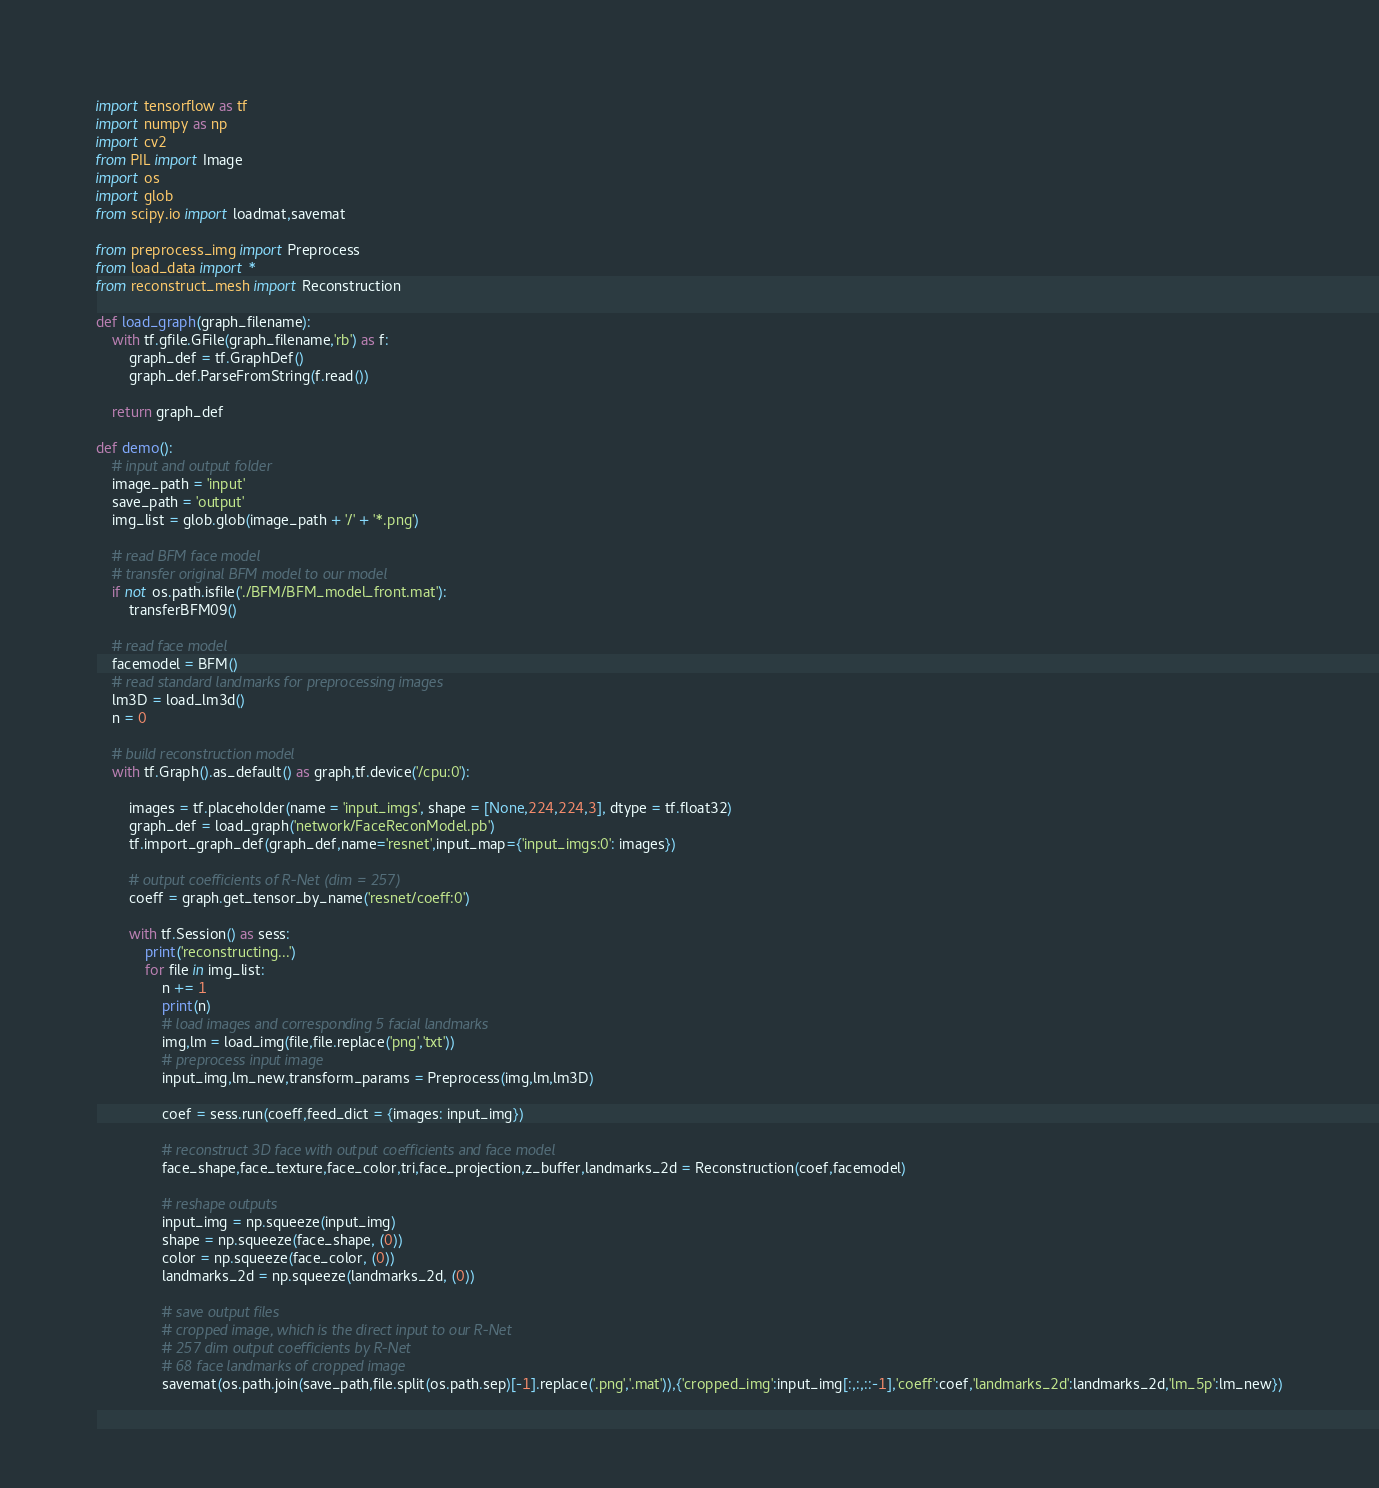Convert code to text. <code><loc_0><loc_0><loc_500><loc_500><_Python_>import tensorflow as tf 
import numpy as np
import cv2
from PIL import Image
import os
import glob
from scipy.io import loadmat,savemat

from preprocess_img import Preprocess
from load_data import *
from reconstruct_mesh import Reconstruction

def load_graph(graph_filename):
	with tf.gfile.GFile(graph_filename,'rb') as f:
		graph_def = tf.GraphDef()
		graph_def.ParseFromString(f.read())

	return graph_def

def demo():
	# input and output folder
	image_path = 'input'
	save_path = 'output'	
	img_list = glob.glob(image_path + '/' + '*.png')

	# read BFM face model
	# transfer original BFM model to our model
	if not os.path.isfile('./BFM/BFM_model_front.mat'):
		transferBFM09()

	# read face model
	facemodel = BFM()
	# read standard landmarks for preprocessing images
	lm3D = load_lm3d()
	n = 0

	# build reconstruction model
	with tf.Graph().as_default() as graph,tf.device('/cpu:0'):

		images = tf.placeholder(name = 'input_imgs', shape = [None,224,224,3], dtype = tf.float32)
		graph_def = load_graph('network/FaceReconModel.pb')
		tf.import_graph_def(graph_def,name='resnet',input_map={'input_imgs:0': images})

		# output coefficients of R-Net (dim = 257) 
		coeff = graph.get_tensor_by_name('resnet/coeff:0')

		with tf.Session() as sess:
			print('reconstructing...')
			for file in img_list:
				n += 1
				print(n)
				# load images and corresponding 5 facial landmarks
				img,lm = load_img(file,file.replace('png','txt'))
				# preprocess input image
				input_img,lm_new,transform_params = Preprocess(img,lm,lm3D)

				coef = sess.run(coeff,feed_dict = {images: input_img})

				# reconstruct 3D face with output coefficients and face model
				face_shape,face_texture,face_color,tri,face_projection,z_buffer,landmarks_2d = Reconstruction(coef,facemodel)

				# reshape outputs
				input_img = np.squeeze(input_img)
				shape = np.squeeze(face_shape, (0))
				color = np.squeeze(face_color, (0))
				landmarks_2d = np.squeeze(landmarks_2d, (0))

				# save output files
				# cropped image, which is the direct input to our R-Net
				# 257 dim output coefficients by R-Net
				# 68 face landmarks of cropped image
				savemat(os.path.join(save_path,file.split(os.path.sep)[-1].replace('.png','.mat')),{'cropped_img':input_img[:,:,::-1],'coeff':coef,'landmarks_2d':landmarks_2d,'lm_5p':lm_new})</code> 